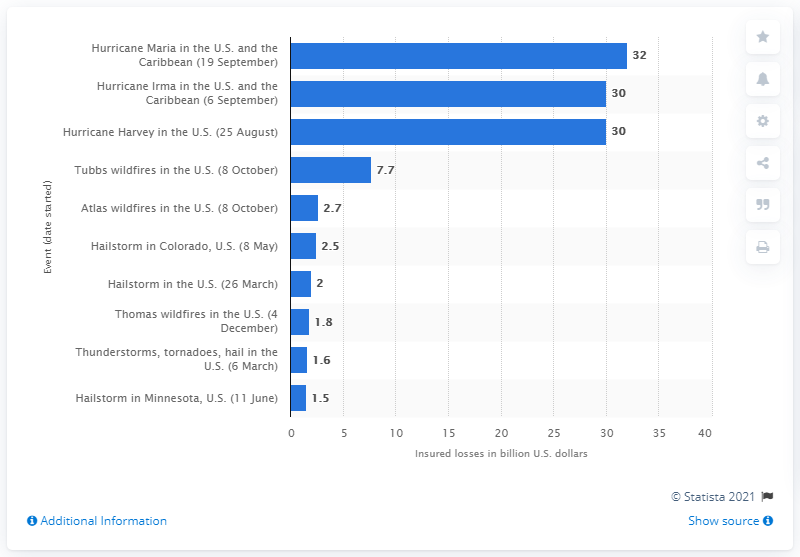Highlight a few significant elements in this photo. Hurricane Maria caused insured losses of approximately $32 billion. 